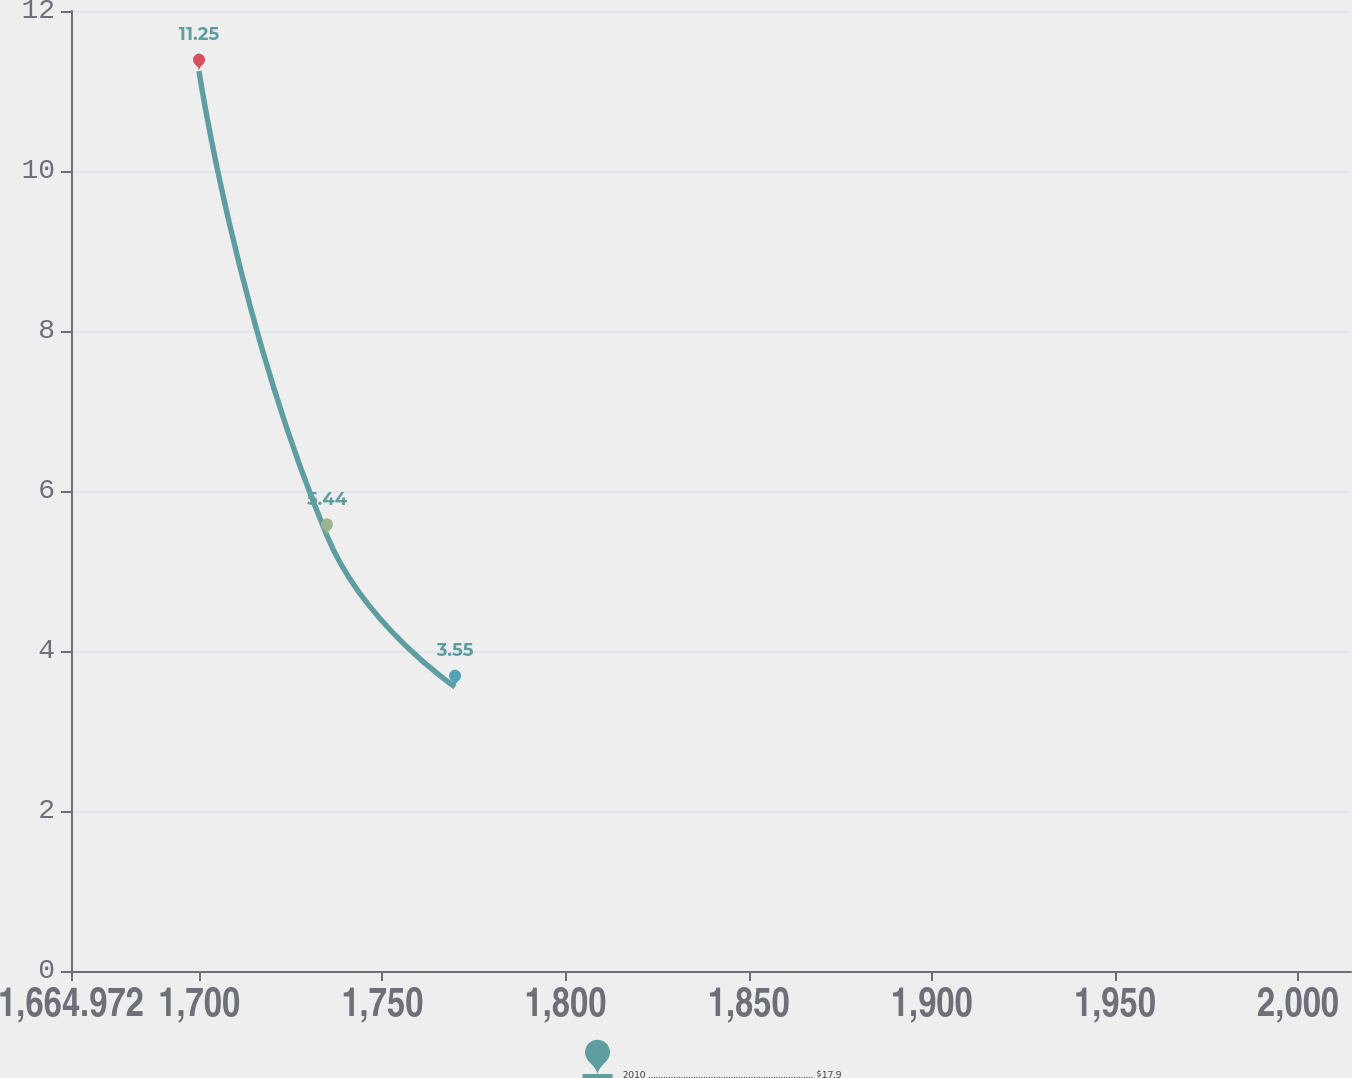Convert chart to OTSL. <chart><loc_0><loc_0><loc_500><loc_500><line_chart><ecel><fcel>2010 .................................................................. $17.9<nl><fcel>1699.92<fcel>11.25<nl><fcel>1734.87<fcel>5.44<nl><fcel>1769.82<fcel>3.55<nl><fcel>2049.4<fcel>4.32<nl></chart> 